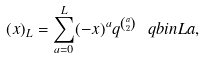<formula> <loc_0><loc_0><loc_500><loc_500>( x ) _ { L } = \sum _ { a = 0 } ^ { L } ( - x ) ^ { a } q ^ { \binom { a } { 2 } } \ q b i n { L } { a } ,</formula> 